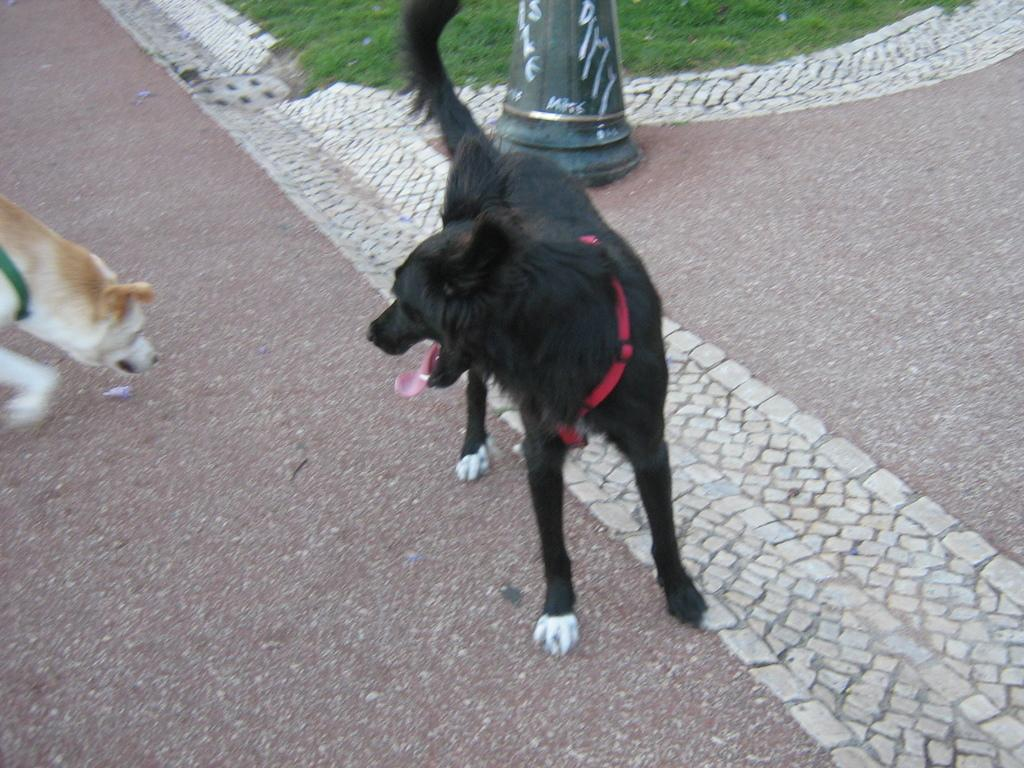What is the main subject in the center of the image? There is a black color dog in the center of the image. Are there any other dogs in the image? Yes, there is another dog on the left side of the image. What can be seen in the background of the image? There appears to be a pole in the image, and grassland is visible. What type of grape is the dog eating in the image? There is no grape present in the image, and the dogs are not eating anything. Can you tell me the judge's opinion on the dogs' behavior in the image? There is no judge present in the image, and the dogs' behavior is not being evaluated. 